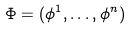Convert formula to latex. <formula><loc_0><loc_0><loc_500><loc_500>\Phi = ( \phi ^ { 1 } , \dots , \phi ^ { n } )</formula> 